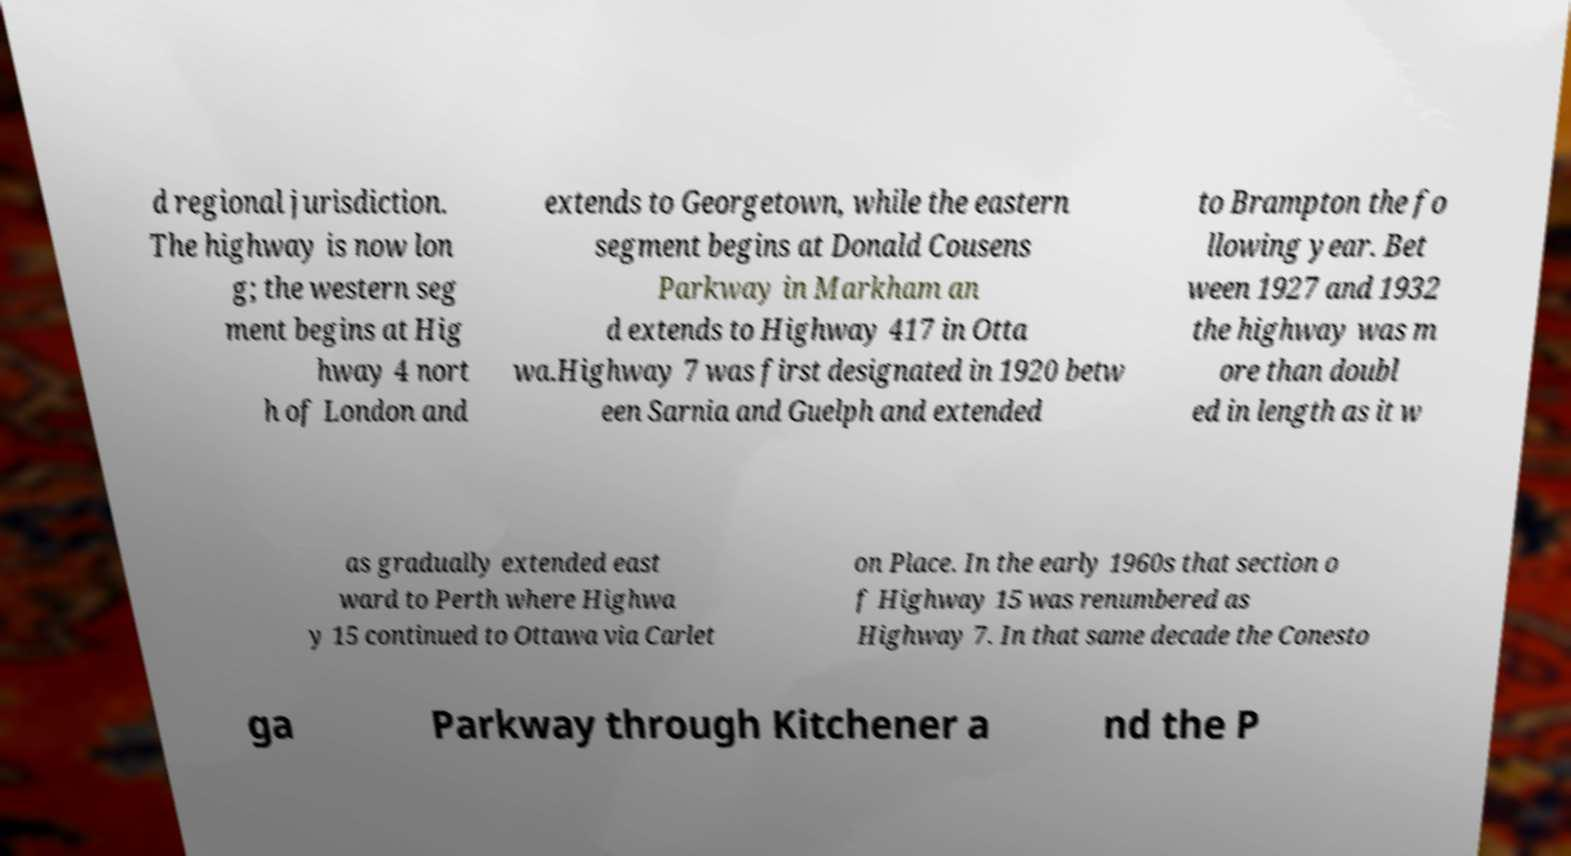Could you extract and type out the text from this image? d regional jurisdiction. The highway is now lon g; the western seg ment begins at Hig hway 4 nort h of London and extends to Georgetown, while the eastern segment begins at Donald Cousens Parkway in Markham an d extends to Highway 417 in Otta wa.Highway 7 was first designated in 1920 betw een Sarnia and Guelph and extended to Brampton the fo llowing year. Bet ween 1927 and 1932 the highway was m ore than doubl ed in length as it w as gradually extended east ward to Perth where Highwa y 15 continued to Ottawa via Carlet on Place. In the early 1960s that section o f Highway 15 was renumbered as Highway 7. In that same decade the Conesto ga Parkway through Kitchener a nd the P 